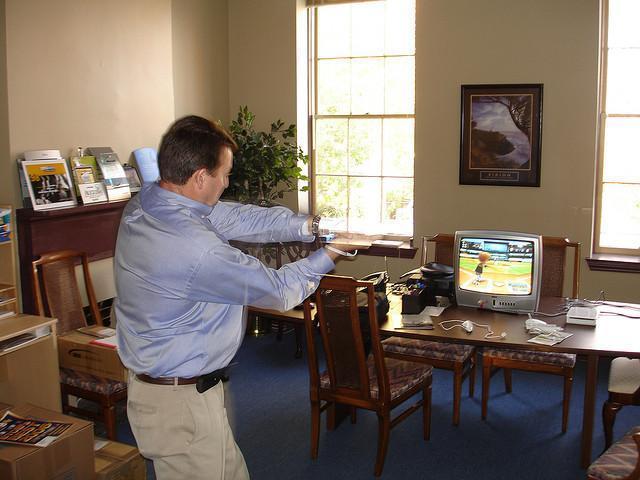How many chairs are in the picture?
Give a very brief answer. 3. How many baby giraffes are there?
Give a very brief answer. 0. 